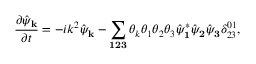<formula> <loc_0><loc_0><loc_500><loc_500>\frac { \partial \hat { \psi } _ { k } } { \partial t } = - i k ^ { 2 } \hat { \psi } _ { k } - \sum _ { 1 2 3 } \theta _ { k } \theta _ { 1 } \theta _ { 2 } \theta _ { 3 } \hat { \psi } _ { 1 } ^ { * } \hat { \psi } _ { 2 } \hat { \psi } _ { 3 } \delta _ { 2 3 } ^ { 0 1 } ,</formula> 